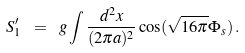<formula> <loc_0><loc_0><loc_500><loc_500>S _ { 1 } ^ { \prime } \ = \ g \int \frac { d ^ { 2 } x } { ( 2 \pi a ) ^ { 2 } } \cos ( \sqrt { 1 6 \pi } \Phi _ { s } ) \, .</formula> 